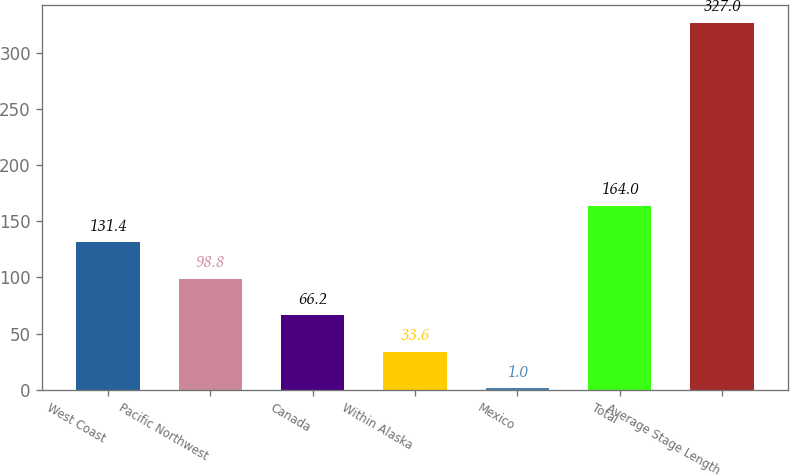Convert chart to OTSL. <chart><loc_0><loc_0><loc_500><loc_500><bar_chart><fcel>West Coast<fcel>Pacific Northwest<fcel>Canada<fcel>Within Alaska<fcel>Mexico<fcel>Total<fcel>Average Stage Length<nl><fcel>131.4<fcel>98.8<fcel>66.2<fcel>33.6<fcel>1<fcel>164<fcel>327<nl></chart> 